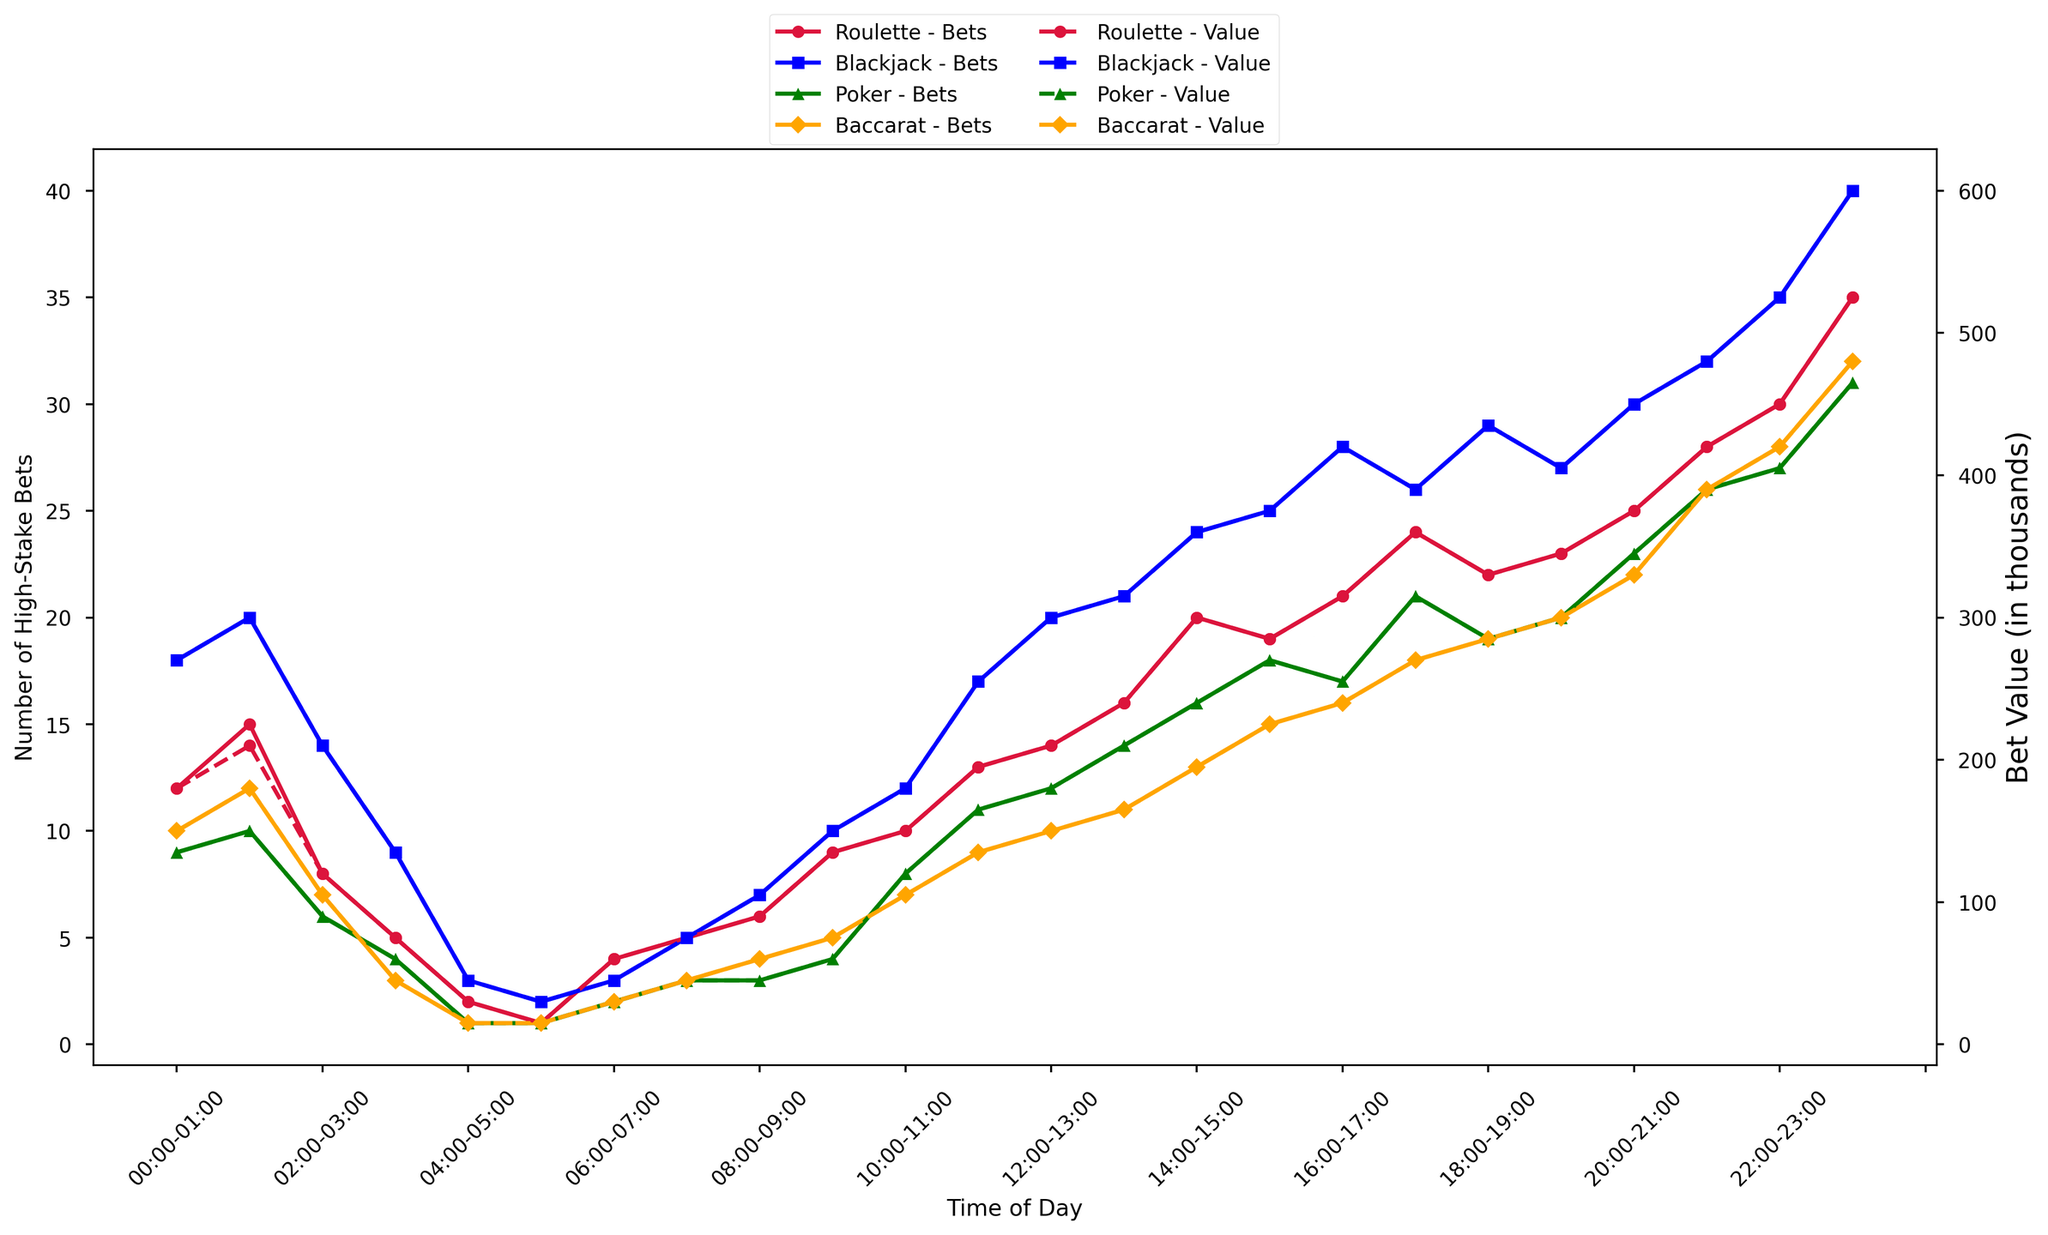Which game type sees the largest number of high-stake bets between 22:00 and 23:00? Compare the number of high-stake bets for each game type during the 22:00-23:00 time slot. Roulette has 30 bets, Blackjack has 35 bets, Poker has 27 bets, and Baccarat has 28 bets. Hence, Blackjack has the largest number of high-stake bets in this period.
Answer: Blackjack How does the bet value in thousands for Blackjack compare to that of Roulette at 00:00-01:00? Examine the bet values for Blackjack and Roulette during the 00:00-01:00 time slot. Blackjack has a bet value of 270 (in thousands), while Roulette has a value of 180 (in thousands). Blackjack's bet value is higher than Roulette's.
Answer: Blackjack has a higher bet value than Roulette At what time of day does Poker have its highest number of high-stake bets, and what is the corresponding bet value in thousands? Find the highest number of high-stake bets for Poker and the corresponding time. This occurs between 23:00 and 00:00 with 31 bets. The corresponding bet value is 465 (in thousands).
Answer: 23:00-00:00, 465 During which time slot does Baccarat and Roulette have the same number of high-stake bets, and what is that number? Compare the number of high-stake bets for Baccarat and Roulette in each time slot. Both have 10 bets during the 10:00-11:00 time slot.
Answer: 10:00-11:00, 10 Which game type shows the most consistent trend in the number of high-stake bets throughout the day? Evaluate the trends of the number of high-stake bets for each game type. Blackjack shows the most consistent increase with fewer sharp fluctuations compared to others.
Answer: Blackjack How does the bet value for Roulette between 21:00 and 22:00 compare to that of Poker in the same time slot? Assess the bet values for both Roulette and Poker between 21:00 and 22:00. Roulette has a bet value of 420 (in thousands), while Poker has a bet value of 390 (in thousands). Roulette's bet value is higher.
Answer: Roulette is higher What is the total number of high-stake bets placed from 08:00 to 09:00 across all game types? Sum the number of high-stake bets for each game type from 08:00 to 09:00. The total is 6 (Roulette) + 7 (Blackjack) + 3 (Poker) + 4 (Baccarat) = 20 bets.
Answer: 20 Which game type has the lowest bet value in thousands between 03:00 and 04:00? Compare the bet values for each game type during the 03:00-04:00 time slot. Roulette has 75 (in thousands), Blackjack has 135 (in thousands), Poker has 60 (in thousands), and Baccarat has 45 (in thousands). Hence, Baccarat has the lowest bet value.
Answer: Baccarat How does the number of high-stake bets for Roulette at 18:00-19:00 compare to that at 00:00-01:00? Compare the number of high-stake bets for Roulette during the 18:00-19:00 and 00:00-01:00 time slots. There are 22 bets at 18:00-19:00 and 12 at 00:00-01:00. The number of high-stake bets is higher at 18:00-19:00.
Answer: Higher at 18:00-19:00 Between 16:00 and 17:00, which game type has the highest bet value in thousands, and what is that value? Compare the bet values for each game type between 16:00 and 17:00. Roulette has 315 (in thousands), Blackjack has 420 (in thousands), Poker has 255 (in thousands), and Baccarat has 240 (in thousands). Blackjack has the highest value.
Answer: Blackjack, 420 